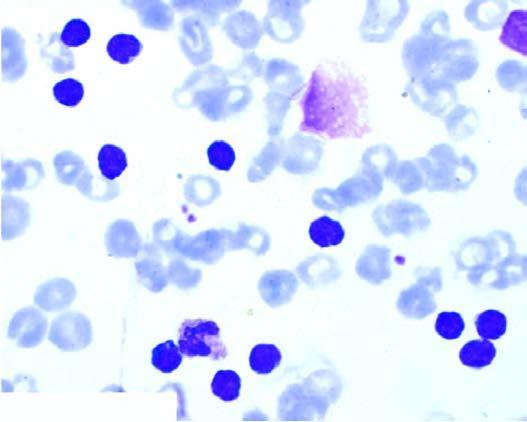s the sectioned surface degenerate forms appearing as bare smudged nuclei?
Answer the question using a single word or phrase. No 